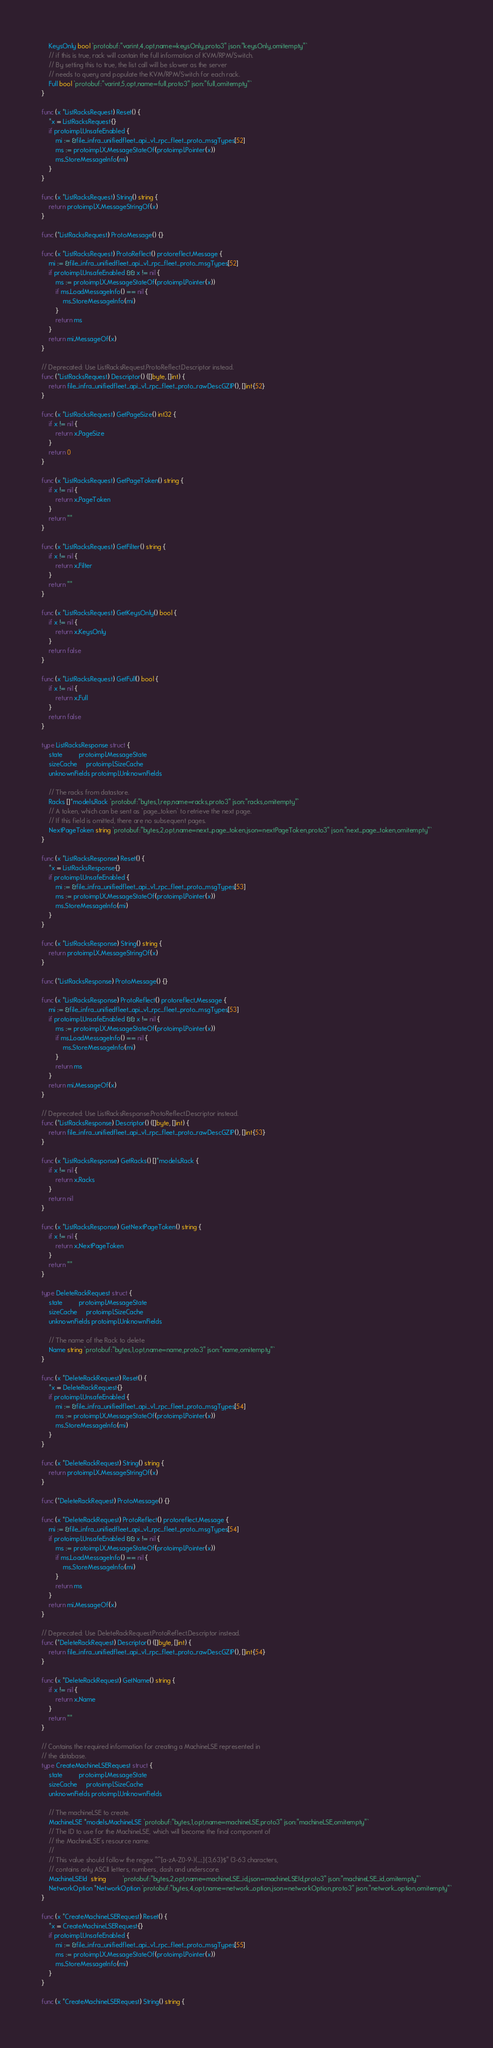<code> <loc_0><loc_0><loc_500><loc_500><_Go_>	KeysOnly bool `protobuf:"varint,4,opt,name=keysOnly,proto3" json:"keysOnly,omitempty"`
	// if this is true, rack will contain the full information of KVM/RPM/Switch.
	// By setting this to true, the list call will be slower as the server
	// needs to query and populate the KVM/RPM/Switch for each rack.
	Full bool `protobuf:"varint,5,opt,name=full,proto3" json:"full,omitempty"`
}

func (x *ListRacksRequest) Reset() {
	*x = ListRacksRequest{}
	if protoimpl.UnsafeEnabled {
		mi := &file_infra_unifiedfleet_api_v1_rpc_fleet_proto_msgTypes[52]
		ms := protoimpl.X.MessageStateOf(protoimpl.Pointer(x))
		ms.StoreMessageInfo(mi)
	}
}

func (x *ListRacksRequest) String() string {
	return protoimpl.X.MessageStringOf(x)
}

func (*ListRacksRequest) ProtoMessage() {}

func (x *ListRacksRequest) ProtoReflect() protoreflect.Message {
	mi := &file_infra_unifiedfleet_api_v1_rpc_fleet_proto_msgTypes[52]
	if protoimpl.UnsafeEnabled && x != nil {
		ms := protoimpl.X.MessageStateOf(protoimpl.Pointer(x))
		if ms.LoadMessageInfo() == nil {
			ms.StoreMessageInfo(mi)
		}
		return ms
	}
	return mi.MessageOf(x)
}

// Deprecated: Use ListRacksRequest.ProtoReflect.Descriptor instead.
func (*ListRacksRequest) Descriptor() ([]byte, []int) {
	return file_infra_unifiedfleet_api_v1_rpc_fleet_proto_rawDescGZIP(), []int{52}
}

func (x *ListRacksRequest) GetPageSize() int32 {
	if x != nil {
		return x.PageSize
	}
	return 0
}

func (x *ListRacksRequest) GetPageToken() string {
	if x != nil {
		return x.PageToken
	}
	return ""
}

func (x *ListRacksRequest) GetFilter() string {
	if x != nil {
		return x.Filter
	}
	return ""
}

func (x *ListRacksRequest) GetKeysOnly() bool {
	if x != nil {
		return x.KeysOnly
	}
	return false
}

func (x *ListRacksRequest) GetFull() bool {
	if x != nil {
		return x.Full
	}
	return false
}

type ListRacksResponse struct {
	state         protoimpl.MessageState
	sizeCache     protoimpl.SizeCache
	unknownFields protoimpl.UnknownFields

	// The racks from datastore.
	Racks []*models.Rack `protobuf:"bytes,1,rep,name=racks,proto3" json:"racks,omitempty"`
	// A token, which can be sent as `page_token` to retrieve the next page.
	// If this field is omitted, there are no subsequent pages.
	NextPageToken string `protobuf:"bytes,2,opt,name=next_page_token,json=nextPageToken,proto3" json:"next_page_token,omitempty"`
}

func (x *ListRacksResponse) Reset() {
	*x = ListRacksResponse{}
	if protoimpl.UnsafeEnabled {
		mi := &file_infra_unifiedfleet_api_v1_rpc_fleet_proto_msgTypes[53]
		ms := protoimpl.X.MessageStateOf(protoimpl.Pointer(x))
		ms.StoreMessageInfo(mi)
	}
}

func (x *ListRacksResponse) String() string {
	return protoimpl.X.MessageStringOf(x)
}

func (*ListRacksResponse) ProtoMessage() {}

func (x *ListRacksResponse) ProtoReflect() protoreflect.Message {
	mi := &file_infra_unifiedfleet_api_v1_rpc_fleet_proto_msgTypes[53]
	if protoimpl.UnsafeEnabled && x != nil {
		ms := protoimpl.X.MessageStateOf(protoimpl.Pointer(x))
		if ms.LoadMessageInfo() == nil {
			ms.StoreMessageInfo(mi)
		}
		return ms
	}
	return mi.MessageOf(x)
}

// Deprecated: Use ListRacksResponse.ProtoReflect.Descriptor instead.
func (*ListRacksResponse) Descriptor() ([]byte, []int) {
	return file_infra_unifiedfleet_api_v1_rpc_fleet_proto_rawDescGZIP(), []int{53}
}

func (x *ListRacksResponse) GetRacks() []*models.Rack {
	if x != nil {
		return x.Racks
	}
	return nil
}

func (x *ListRacksResponse) GetNextPageToken() string {
	if x != nil {
		return x.NextPageToken
	}
	return ""
}

type DeleteRackRequest struct {
	state         protoimpl.MessageState
	sizeCache     protoimpl.SizeCache
	unknownFields protoimpl.UnknownFields

	// The name of the Rack to delete
	Name string `protobuf:"bytes,1,opt,name=name,proto3" json:"name,omitempty"`
}

func (x *DeleteRackRequest) Reset() {
	*x = DeleteRackRequest{}
	if protoimpl.UnsafeEnabled {
		mi := &file_infra_unifiedfleet_api_v1_rpc_fleet_proto_msgTypes[54]
		ms := protoimpl.X.MessageStateOf(protoimpl.Pointer(x))
		ms.StoreMessageInfo(mi)
	}
}

func (x *DeleteRackRequest) String() string {
	return protoimpl.X.MessageStringOf(x)
}

func (*DeleteRackRequest) ProtoMessage() {}

func (x *DeleteRackRequest) ProtoReflect() protoreflect.Message {
	mi := &file_infra_unifiedfleet_api_v1_rpc_fleet_proto_msgTypes[54]
	if protoimpl.UnsafeEnabled && x != nil {
		ms := protoimpl.X.MessageStateOf(protoimpl.Pointer(x))
		if ms.LoadMessageInfo() == nil {
			ms.StoreMessageInfo(mi)
		}
		return ms
	}
	return mi.MessageOf(x)
}

// Deprecated: Use DeleteRackRequest.ProtoReflect.Descriptor instead.
func (*DeleteRackRequest) Descriptor() ([]byte, []int) {
	return file_infra_unifiedfleet_api_v1_rpc_fleet_proto_rawDescGZIP(), []int{54}
}

func (x *DeleteRackRequest) GetName() string {
	if x != nil {
		return x.Name
	}
	return ""
}

// Contains the required information for creating a MachineLSE represented in
// the database.
type CreateMachineLSERequest struct {
	state         protoimpl.MessageState
	sizeCache     protoimpl.SizeCache
	unknownFields protoimpl.UnknownFields

	// The machineLSE to create.
	MachineLSE *models.MachineLSE `protobuf:"bytes,1,opt,name=machineLSE,proto3" json:"machineLSE,omitempty"`
	// The ID to use for the MachineLSE, which will become the final component of
	// the MachineLSE's resource name.
	//
	// This value should follow the regex "^[a-zA-Z0-9-)(_:.]{3,63}$" (3-63 characters,
	// contains only ASCII letters, numbers, dash and underscore.
	MachineLSEId  string         `protobuf:"bytes,2,opt,name=machineLSE_id,json=machineLSEId,proto3" json:"machineLSE_id,omitempty"`
	NetworkOption *NetworkOption `protobuf:"bytes,4,opt,name=network_option,json=networkOption,proto3" json:"network_option,omitempty"`
}

func (x *CreateMachineLSERequest) Reset() {
	*x = CreateMachineLSERequest{}
	if protoimpl.UnsafeEnabled {
		mi := &file_infra_unifiedfleet_api_v1_rpc_fleet_proto_msgTypes[55]
		ms := protoimpl.X.MessageStateOf(protoimpl.Pointer(x))
		ms.StoreMessageInfo(mi)
	}
}

func (x *CreateMachineLSERequest) String() string {</code> 